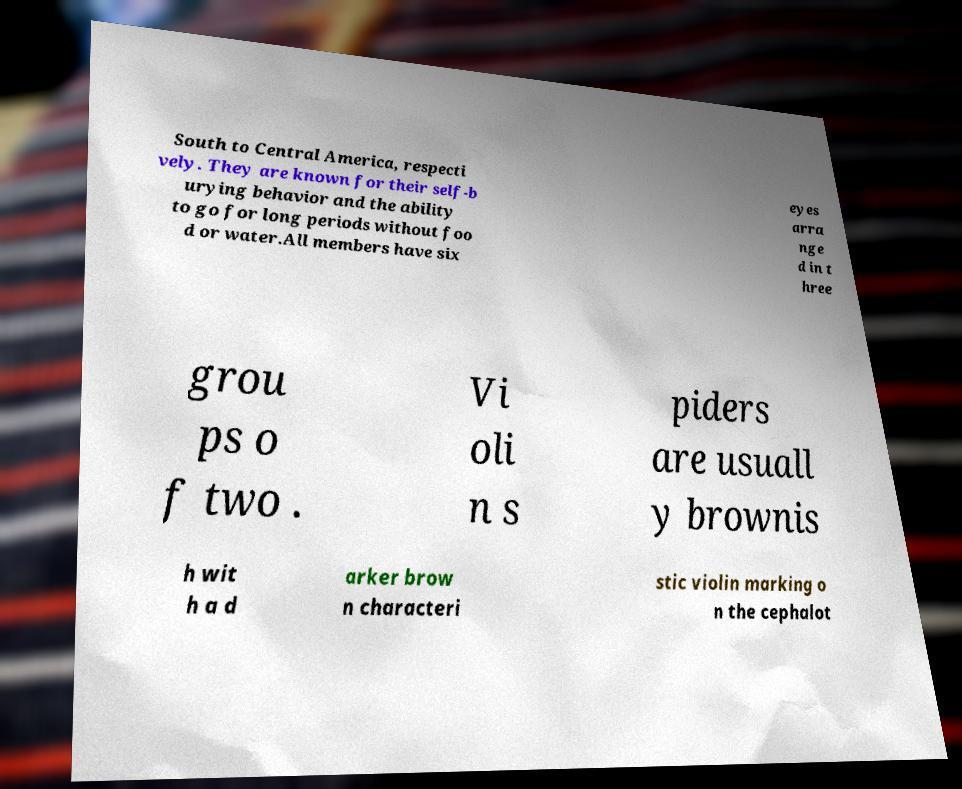Can you read and provide the text displayed in the image?This photo seems to have some interesting text. Can you extract and type it out for me? South to Central America, respecti vely. They are known for their self-b urying behavior and the ability to go for long periods without foo d or water.All members have six eyes arra nge d in t hree grou ps o f two . Vi oli n s piders are usuall y brownis h wit h a d arker brow n characteri stic violin marking o n the cephalot 